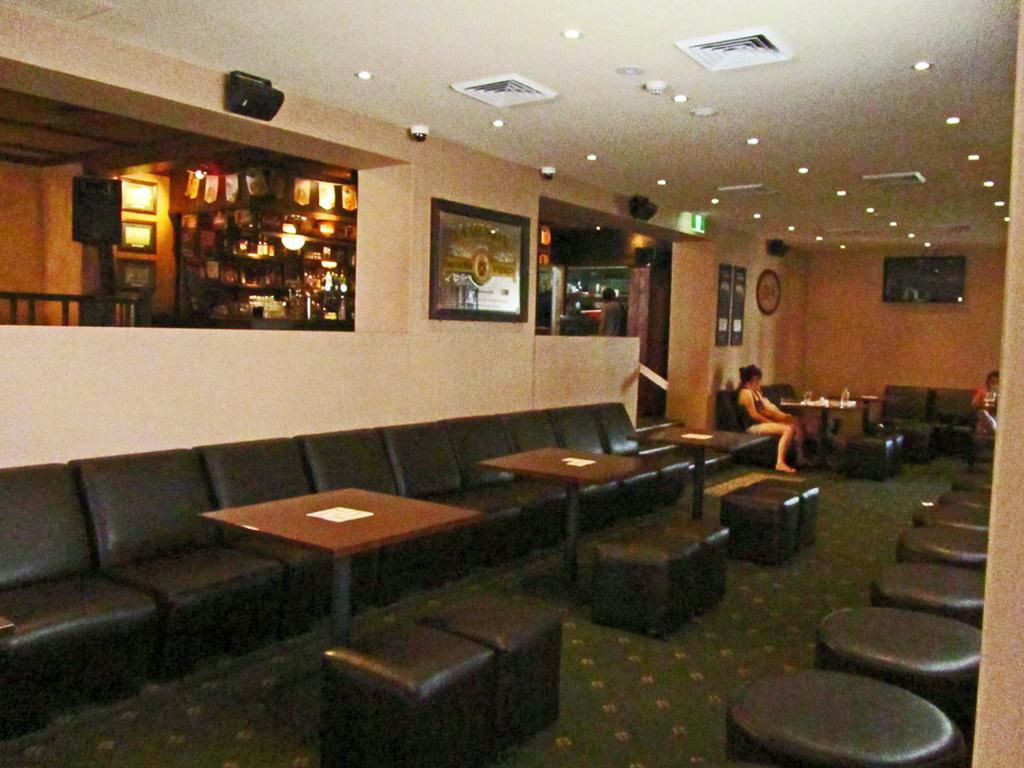What are the people in the room doing? The people sitting in the room are likely engaged in some activity or conversation. What type of furniture is present in the room? There is a chair and a bedside table in the room. What can be found on the walls of the room? There is a speaker, a frame, and posters on the wall. What is mounted on the wall opposite the people? There is a TV on the wall. Can you describe any objects on the roof of the room? There is a camera and lights on the roof. What type of cap is hanging from the camera on the roof? There is no cap present in the image; the camera is mounted on the roof without any visible accessories. 